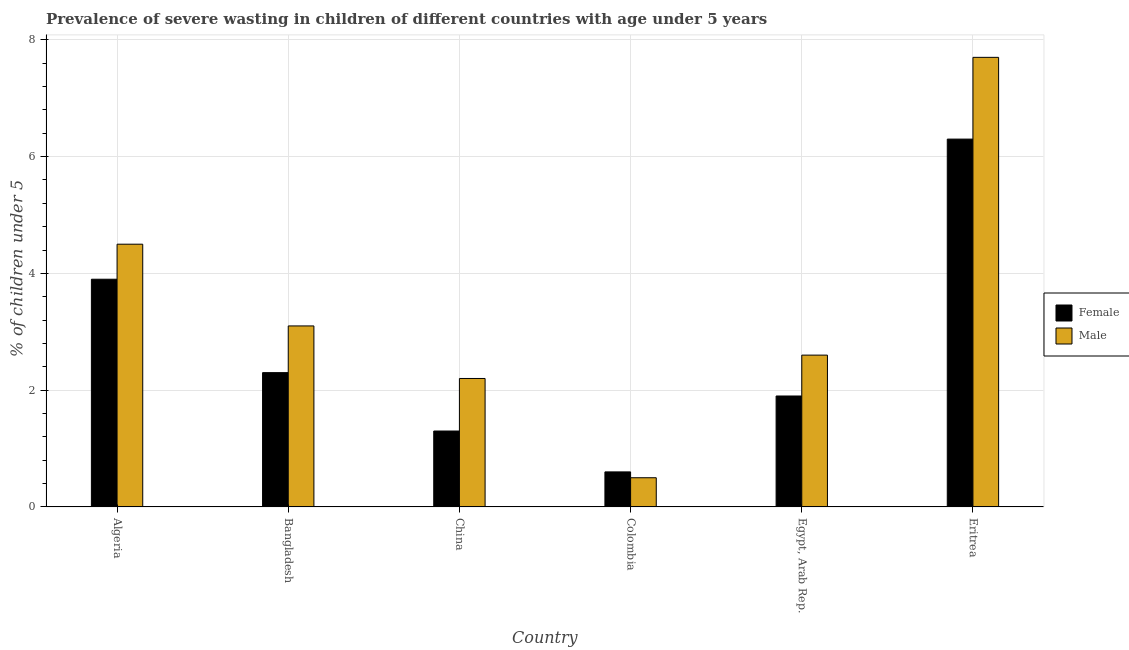How many different coloured bars are there?
Offer a terse response. 2. How many groups of bars are there?
Keep it short and to the point. 6. How many bars are there on the 4th tick from the left?
Make the answer very short. 2. How many bars are there on the 4th tick from the right?
Make the answer very short. 2. What is the label of the 6th group of bars from the left?
Provide a succinct answer. Eritrea. In how many cases, is the number of bars for a given country not equal to the number of legend labels?
Your answer should be compact. 0. What is the percentage of undernourished female children in Egypt, Arab Rep.?
Make the answer very short. 1.9. Across all countries, what is the maximum percentage of undernourished female children?
Your answer should be very brief. 6.3. Across all countries, what is the minimum percentage of undernourished female children?
Your answer should be very brief. 0.6. In which country was the percentage of undernourished female children maximum?
Your answer should be compact. Eritrea. In which country was the percentage of undernourished male children minimum?
Your answer should be compact. Colombia. What is the total percentage of undernourished male children in the graph?
Your response must be concise. 20.6. What is the difference between the percentage of undernourished female children in Algeria and that in Egypt, Arab Rep.?
Make the answer very short. 2. What is the difference between the percentage of undernourished male children in China and the percentage of undernourished female children in Egypt, Arab Rep.?
Your answer should be compact. 0.3. What is the average percentage of undernourished female children per country?
Your answer should be compact. 2.72. What is the difference between the percentage of undernourished male children and percentage of undernourished female children in Colombia?
Provide a short and direct response. -0.1. What is the ratio of the percentage of undernourished female children in Algeria to that in Egypt, Arab Rep.?
Ensure brevity in your answer.  2.05. Is the percentage of undernourished female children in Bangladesh less than that in Egypt, Arab Rep.?
Keep it short and to the point. No. Is the difference between the percentage of undernourished male children in Algeria and Egypt, Arab Rep. greater than the difference between the percentage of undernourished female children in Algeria and Egypt, Arab Rep.?
Keep it short and to the point. No. What is the difference between the highest and the second highest percentage of undernourished female children?
Your response must be concise. 2.4. What is the difference between the highest and the lowest percentage of undernourished male children?
Your answer should be compact. 7.2. In how many countries, is the percentage of undernourished male children greater than the average percentage of undernourished male children taken over all countries?
Offer a terse response. 2. Is the sum of the percentage of undernourished female children in Egypt, Arab Rep. and Eritrea greater than the maximum percentage of undernourished male children across all countries?
Provide a succinct answer. Yes. What does the 2nd bar from the right in Egypt, Arab Rep. represents?
Your answer should be very brief. Female. Does the graph contain any zero values?
Offer a terse response. No. How many legend labels are there?
Your answer should be very brief. 2. What is the title of the graph?
Keep it short and to the point. Prevalence of severe wasting in children of different countries with age under 5 years. Does "Mobile cellular" appear as one of the legend labels in the graph?
Your answer should be compact. No. What is the label or title of the Y-axis?
Your answer should be very brief.  % of children under 5. What is the  % of children under 5 in Female in Algeria?
Provide a short and direct response. 3.9. What is the  % of children under 5 of Male in Algeria?
Provide a short and direct response. 4.5. What is the  % of children under 5 of Female in Bangladesh?
Your answer should be compact. 2.3. What is the  % of children under 5 in Male in Bangladesh?
Ensure brevity in your answer.  3.1. What is the  % of children under 5 in Female in China?
Make the answer very short. 1.3. What is the  % of children under 5 of Male in China?
Give a very brief answer. 2.2. What is the  % of children under 5 in Female in Colombia?
Offer a very short reply. 0.6. What is the  % of children under 5 in Male in Colombia?
Offer a terse response. 0.5. What is the  % of children under 5 in Female in Egypt, Arab Rep.?
Provide a succinct answer. 1.9. What is the  % of children under 5 of Male in Egypt, Arab Rep.?
Your response must be concise. 2.6. What is the  % of children under 5 of Female in Eritrea?
Keep it short and to the point. 6.3. What is the  % of children under 5 in Male in Eritrea?
Keep it short and to the point. 7.7. Across all countries, what is the maximum  % of children under 5 in Female?
Keep it short and to the point. 6.3. Across all countries, what is the maximum  % of children under 5 of Male?
Make the answer very short. 7.7. Across all countries, what is the minimum  % of children under 5 of Female?
Give a very brief answer. 0.6. Across all countries, what is the minimum  % of children under 5 of Male?
Provide a succinct answer. 0.5. What is the total  % of children under 5 of Female in the graph?
Your response must be concise. 16.3. What is the total  % of children under 5 of Male in the graph?
Offer a very short reply. 20.6. What is the difference between the  % of children under 5 of Male in Algeria and that in Egypt, Arab Rep.?
Ensure brevity in your answer.  1.9. What is the difference between the  % of children under 5 of Female in Bangladesh and that in China?
Make the answer very short. 1. What is the difference between the  % of children under 5 in Male in Bangladesh and that in China?
Offer a terse response. 0.9. What is the difference between the  % of children under 5 of Female in Bangladesh and that in Colombia?
Your response must be concise. 1.7. What is the difference between the  % of children under 5 of Female in Bangladesh and that in Eritrea?
Your response must be concise. -4. What is the difference between the  % of children under 5 of Female in China and that in Egypt, Arab Rep.?
Keep it short and to the point. -0.6. What is the difference between the  % of children under 5 in Female in China and that in Eritrea?
Your response must be concise. -5. What is the difference between the  % of children under 5 of Female in Colombia and that in Egypt, Arab Rep.?
Ensure brevity in your answer.  -1.3. What is the difference between the  % of children under 5 in Male in Colombia and that in Egypt, Arab Rep.?
Provide a succinct answer. -2.1. What is the difference between the  % of children under 5 of Female in Egypt, Arab Rep. and that in Eritrea?
Give a very brief answer. -4.4. What is the difference between the  % of children under 5 of Female in Algeria and the  % of children under 5 of Male in China?
Give a very brief answer. 1.7. What is the difference between the  % of children under 5 in Female in Bangladesh and the  % of children under 5 in Male in China?
Give a very brief answer. 0.1. What is the difference between the  % of children under 5 in Female in Bangladesh and the  % of children under 5 in Male in Colombia?
Your answer should be very brief. 1.8. What is the difference between the  % of children under 5 of Female in Bangladesh and the  % of children under 5 of Male in Eritrea?
Your response must be concise. -5.4. What is the difference between the  % of children under 5 in Female in China and the  % of children under 5 in Male in Egypt, Arab Rep.?
Offer a very short reply. -1.3. What is the difference between the  % of children under 5 of Female in Colombia and the  % of children under 5 of Male in Eritrea?
Your answer should be compact. -7.1. What is the difference between the  % of children under 5 in Female in Egypt, Arab Rep. and the  % of children under 5 in Male in Eritrea?
Offer a terse response. -5.8. What is the average  % of children under 5 in Female per country?
Make the answer very short. 2.72. What is the average  % of children under 5 of Male per country?
Provide a succinct answer. 3.43. What is the difference between the  % of children under 5 of Female and  % of children under 5 of Male in Algeria?
Keep it short and to the point. -0.6. What is the difference between the  % of children under 5 of Female and  % of children under 5 of Male in Bangladesh?
Your answer should be compact. -0.8. What is the difference between the  % of children under 5 of Female and  % of children under 5 of Male in Colombia?
Your answer should be very brief. 0.1. What is the difference between the  % of children under 5 in Female and  % of children under 5 in Male in Egypt, Arab Rep.?
Ensure brevity in your answer.  -0.7. What is the difference between the  % of children under 5 in Female and  % of children under 5 in Male in Eritrea?
Make the answer very short. -1.4. What is the ratio of the  % of children under 5 in Female in Algeria to that in Bangladesh?
Offer a terse response. 1.7. What is the ratio of the  % of children under 5 of Male in Algeria to that in Bangladesh?
Your response must be concise. 1.45. What is the ratio of the  % of children under 5 in Male in Algeria to that in China?
Your answer should be compact. 2.05. What is the ratio of the  % of children under 5 in Female in Algeria to that in Colombia?
Your answer should be compact. 6.5. What is the ratio of the  % of children under 5 in Female in Algeria to that in Egypt, Arab Rep.?
Ensure brevity in your answer.  2.05. What is the ratio of the  % of children under 5 in Male in Algeria to that in Egypt, Arab Rep.?
Offer a very short reply. 1.73. What is the ratio of the  % of children under 5 in Female in Algeria to that in Eritrea?
Make the answer very short. 0.62. What is the ratio of the  % of children under 5 in Male in Algeria to that in Eritrea?
Your response must be concise. 0.58. What is the ratio of the  % of children under 5 in Female in Bangladesh to that in China?
Your response must be concise. 1.77. What is the ratio of the  % of children under 5 of Male in Bangladesh to that in China?
Offer a terse response. 1.41. What is the ratio of the  % of children under 5 in Female in Bangladesh to that in Colombia?
Your answer should be compact. 3.83. What is the ratio of the  % of children under 5 in Female in Bangladesh to that in Egypt, Arab Rep.?
Offer a terse response. 1.21. What is the ratio of the  % of children under 5 in Male in Bangladesh to that in Egypt, Arab Rep.?
Your answer should be very brief. 1.19. What is the ratio of the  % of children under 5 in Female in Bangladesh to that in Eritrea?
Provide a short and direct response. 0.37. What is the ratio of the  % of children under 5 in Male in Bangladesh to that in Eritrea?
Your response must be concise. 0.4. What is the ratio of the  % of children under 5 in Female in China to that in Colombia?
Your response must be concise. 2.17. What is the ratio of the  % of children under 5 in Male in China to that in Colombia?
Provide a succinct answer. 4.4. What is the ratio of the  % of children under 5 in Female in China to that in Egypt, Arab Rep.?
Offer a very short reply. 0.68. What is the ratio of the  % of children under 5 of Male in China to that in Egypt, Arab Rep.?
Keep it short and to the point. 0.85. What is the ratio of the  % of children under 5 in Female in China to that in Eritrea?
Your answer should be compact. 0.21. What is the ratio of the  % of children under 5 in Male in China to that in Eritrea?
Your answer should be very brief. 0.29. What is the ratio of the  % of children under 5 of Female in Colombia to that in Egypt, Arab Rep.?
Your answer should be compact. 0.32. What is the ratio of the  % of children under 5 of Male in Colombia to that in Egypt, Arab Rep.?
Offer a very short reply. 0.19. What is the ratio of the  % of children under 5 of Female in Colombia to that in Eritrea?
Offer a terse response. 0.1. What is the ratio of the  % of children under 5 of Male in Colombia to that in Eritrea?
Offer a very short reply. 0.06. What is the ratio of the  % of children under 5 in Female in Egypt, Arab Rep. to that in Eritrea?
Give a very brief answer. 0.3. What is the ratio of the  % of children under 5 in Male in Egypt, Arab Rep. to that in Eritrea?
Provide a short and direct response. 0.34. What is the difference between the highest and the second highest  % of children under 5 in Male?
Your answer should be compact. 3.2. What is the difference between the highest and the lowest  % of children under 5 in Female?
Ensure brevity in your answer.  5.7. 